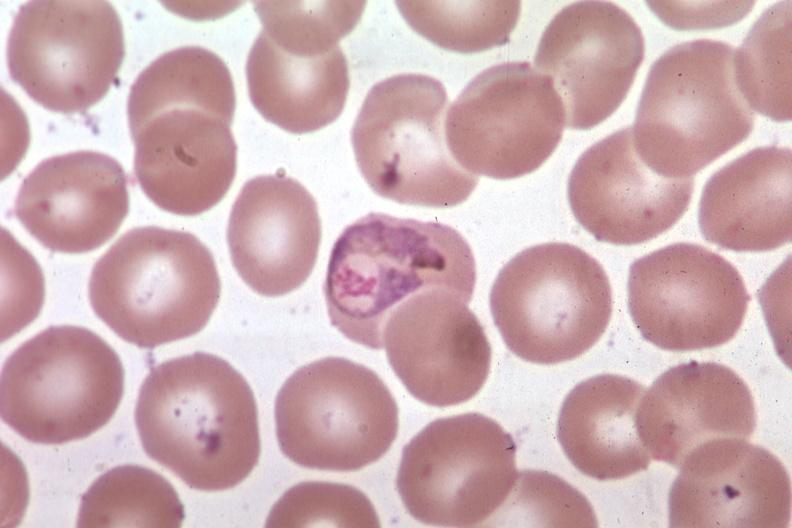s hematologic present?
Answer the question using a single word or phrase. Yes 